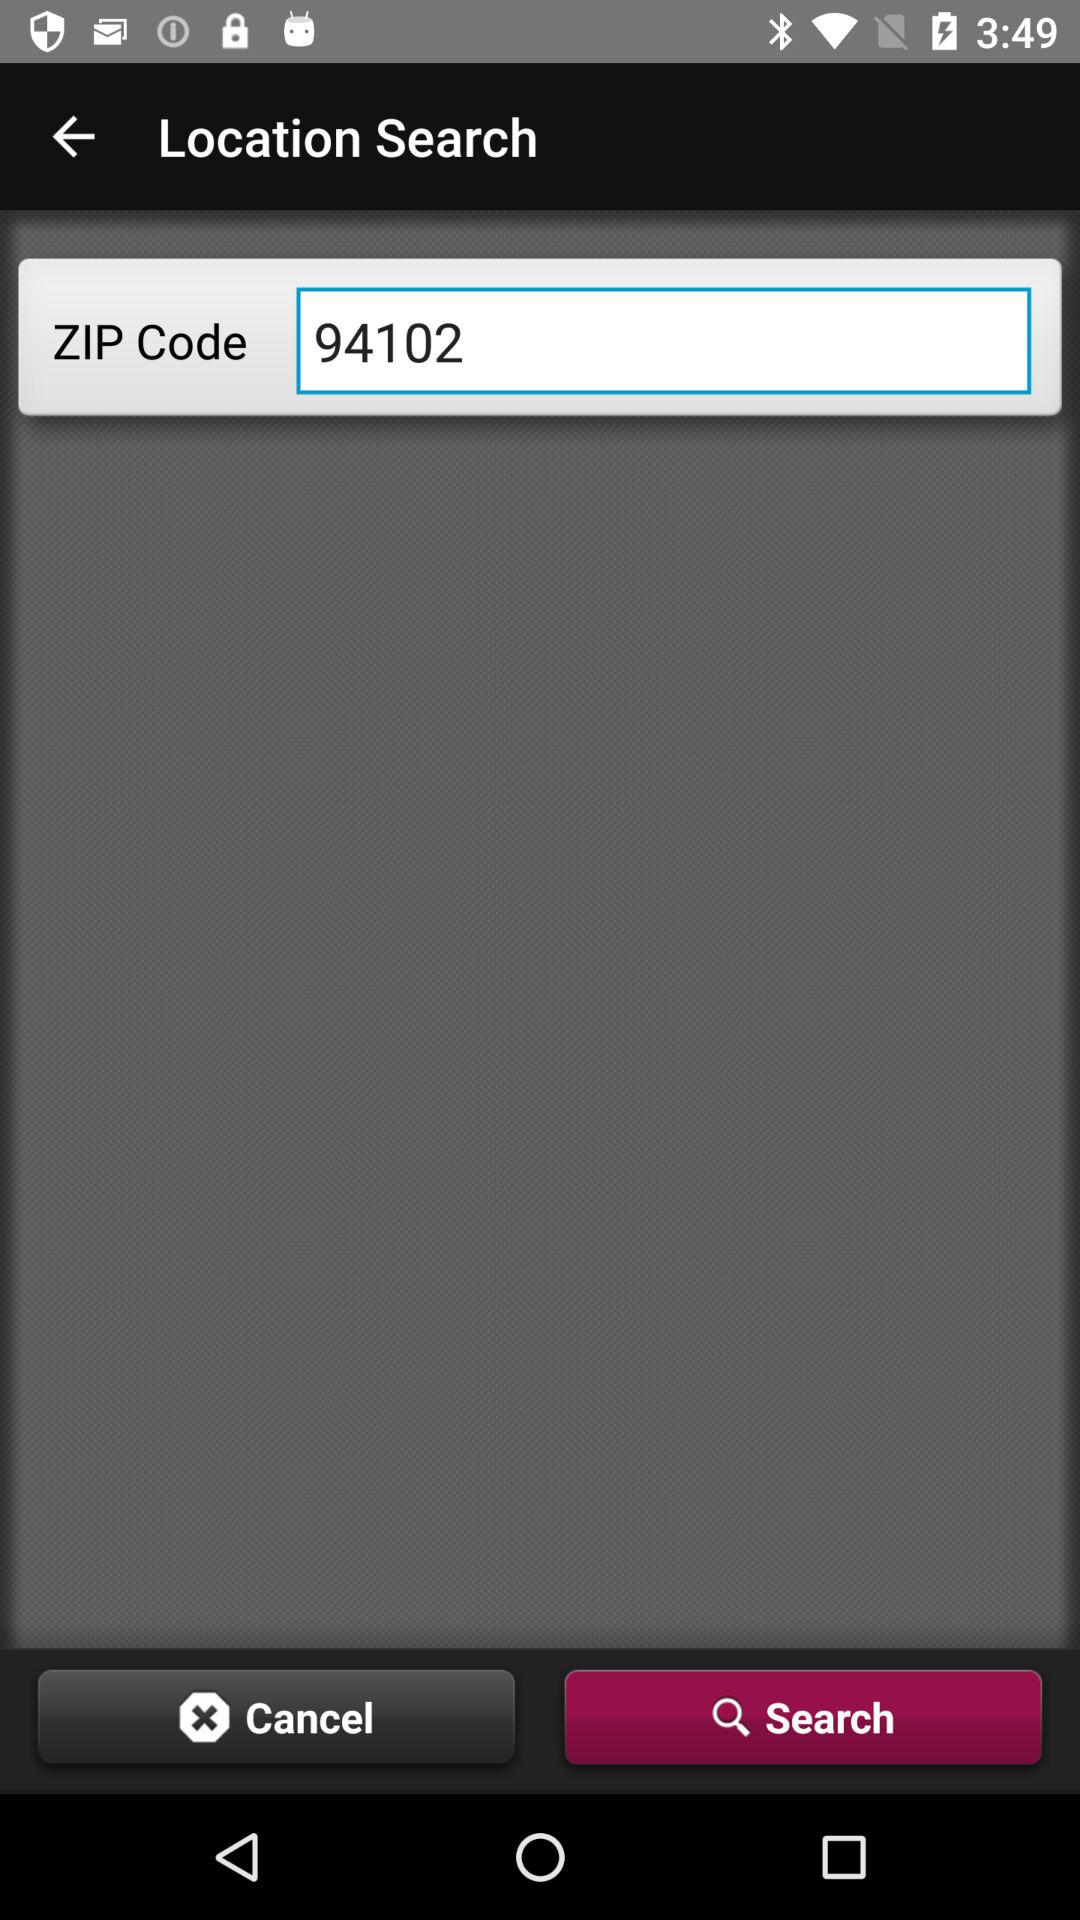What is the zip code? The zip code is 94102. 